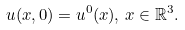<formula> <loc_0><loc_0><loc_500><loc_500>u ( x , 0 ) = u ^ { 0 } ( x ) , \, x \in \mathbb { R } ^ { 3 } .</formula> 